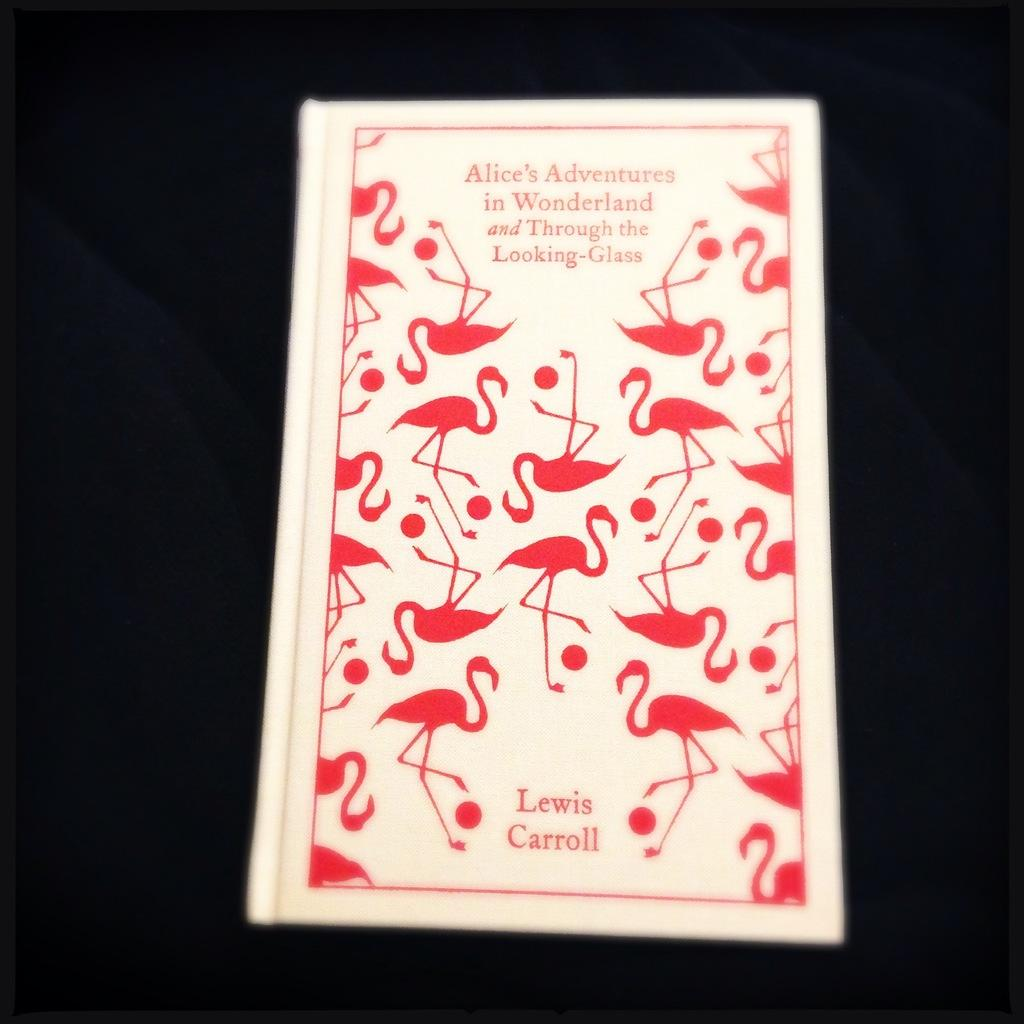<image>
Write a terse but informative summary of the picture. A novel pink and white cover of a Lewis Carroll book. 